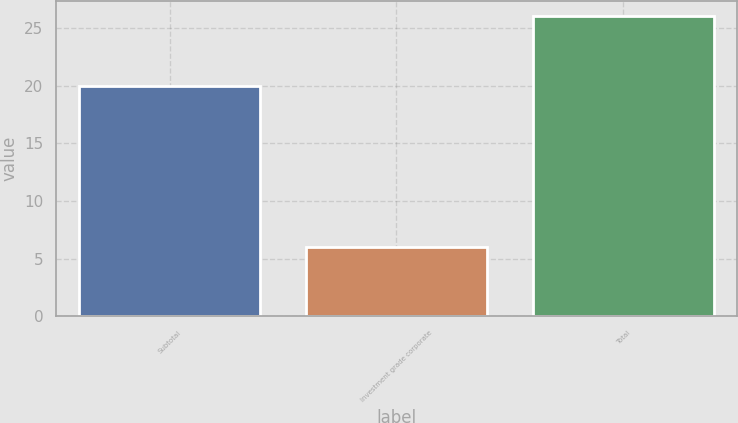Convert chart. <chart><loc_0><loc_0><loc_500><loc_500><bar_chart><fcel>Subtotal<fcel>Investment grade corporate<fcel>Total<nl><fcel>20<fcel>6<fcel>26<nl></chart> 